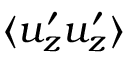Convert formula to latex. <formula><loc_0><loc_0><loc_500><loc_500>\langle u _ { z } ^ { \prime } u _ { z } ^ { \prime } \rangle</formula> 